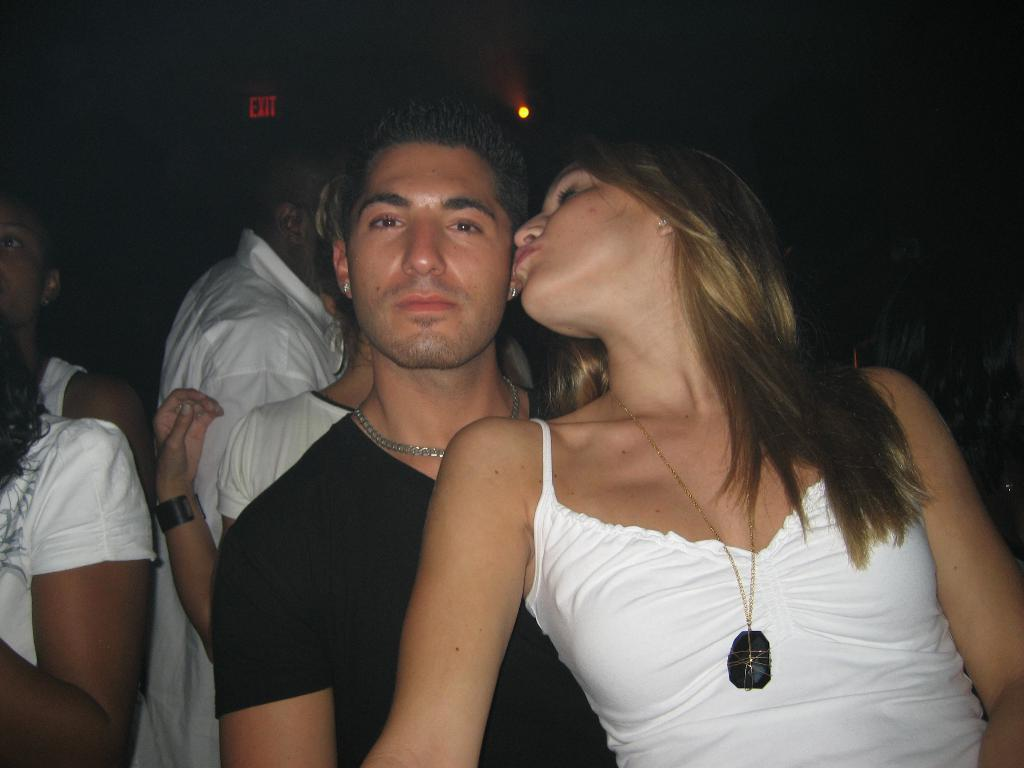Who or what can be seen in the image? There are people in the image. What is the color of the background in the image? The background of the image is dark. Can you identify any light source in the image? Yes, there is a light visible in the image. How many geese are flying in the image? There are no geese present in the image. What type of ray is visible in the image? There is no ray visible in the image. 